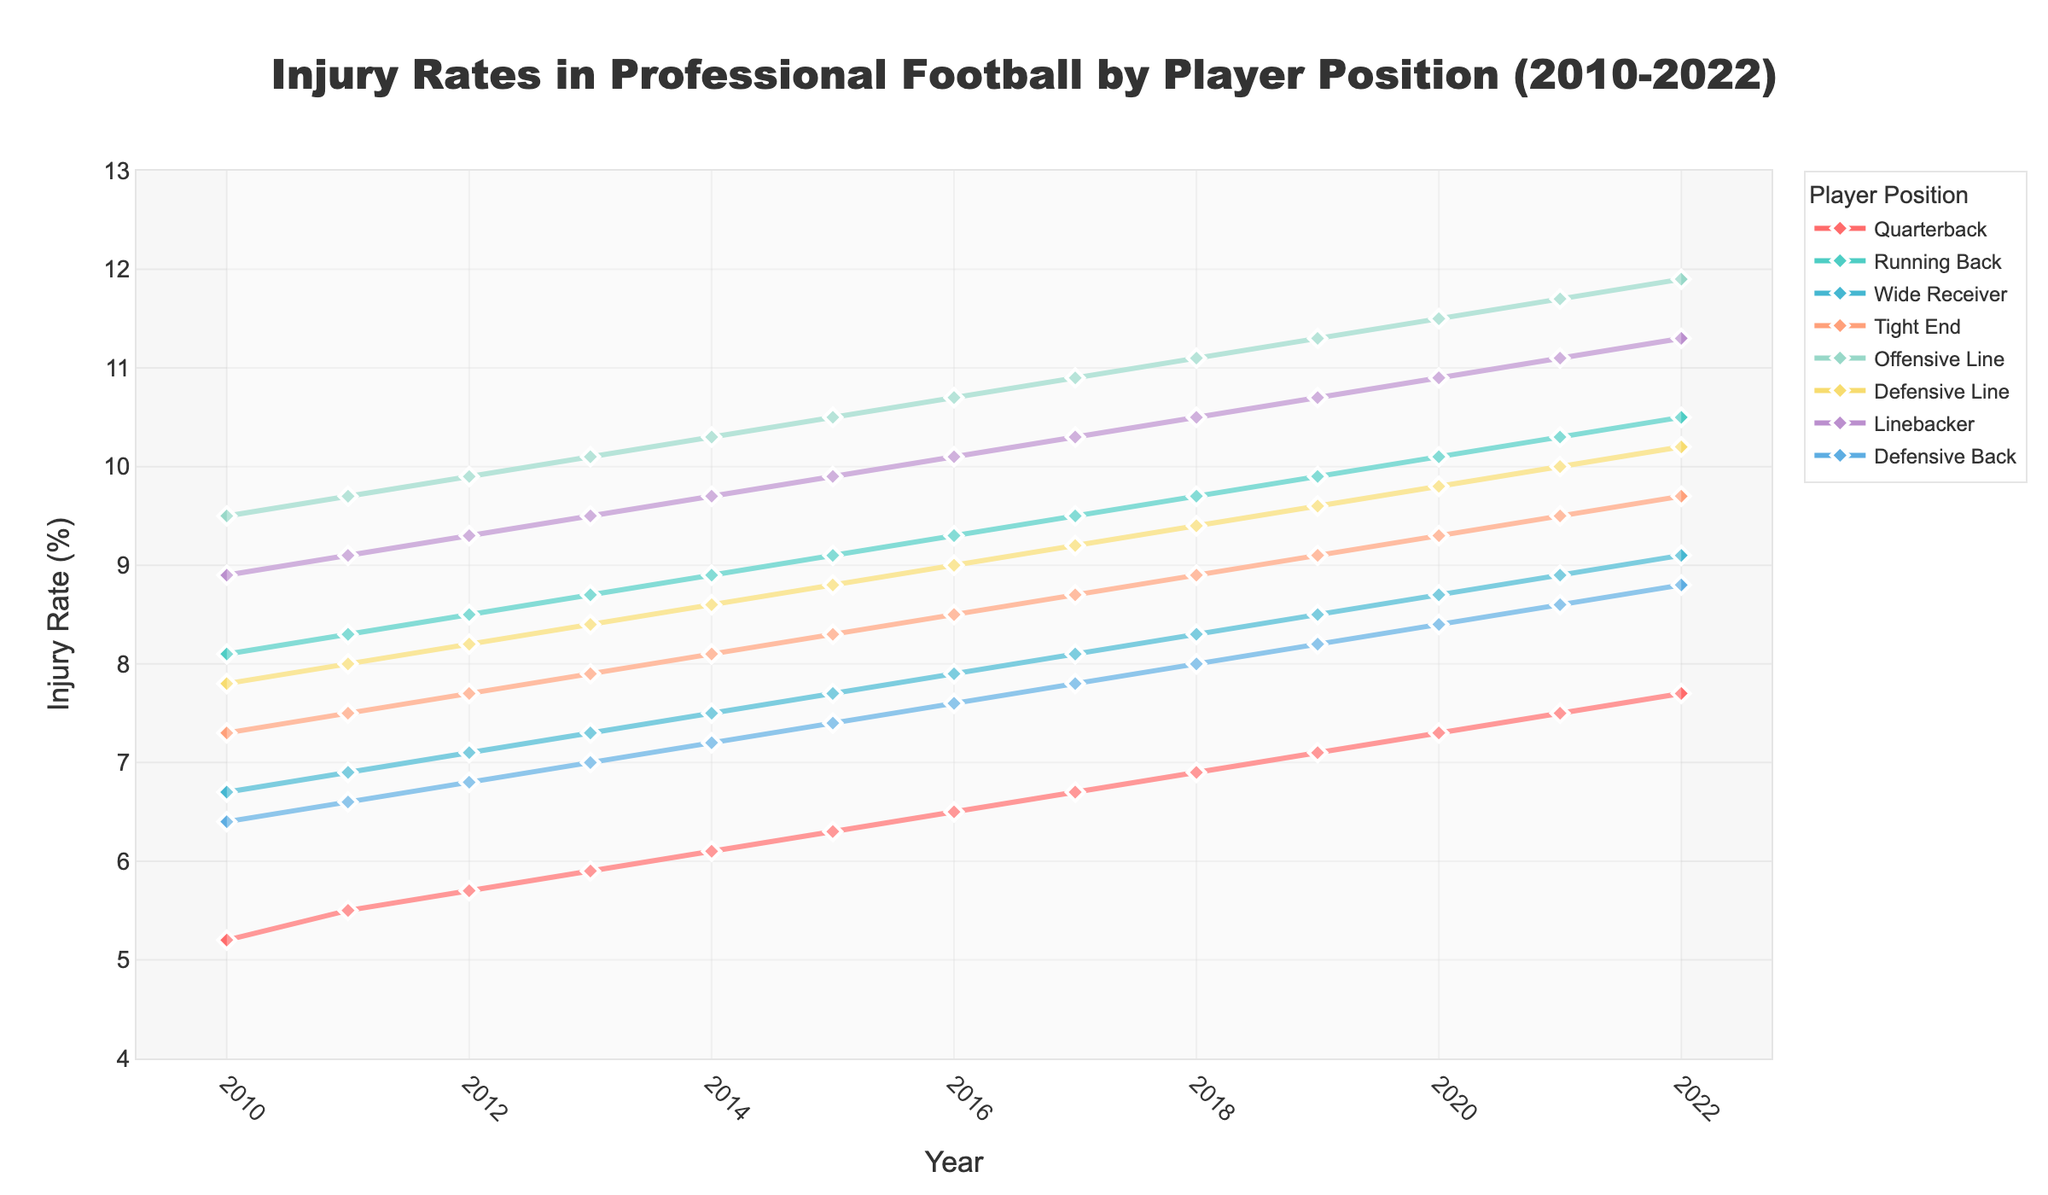Which player position had the highest injury rate in 2022? Look at the injury rates across all player positions for the year 2022. Identify the highest value among them.
Answer: Offensive Line How has the injury rate for Quarterbacks changed from 2010 to 2022? Observe the injury rates for Quarterbacks from 2010 to 2022. Note the initial rate in 2010 and the final rate in 2022 and calculate the difference.
Answer: Increased by 2.5% Which player position shows the most significant increase in injury rates over the years? Compare the starting and ending injury rates for each player position from 2010 to 2022. Determine which position has the largest increase.
Answer: Offensive Line In which year did the Wide Receiver position see the highest injury rate? Review the injury rates for Wide Receivers across all years from 2010 to 2022. Identify the year with the highest rate.
Answer: 2022 What is the average injury rate for Defensive Line players from 2010 to 2022? Calculate the sum of the injury rates for Defensive Line players for each year from 2010 to 2022. Divide the total by the number of years (13).
Answer: 9.2% How do the injury rates for Running Backs and Linebackers compare in 2015? Look at the injury rates for Running Backs and Linebackers in 2015. Compare the values to see which is higher, lower, or if they are equal.
Answer: Linebackers have a higher injury rate Between 2010 and 2022, which position had the least overall variation in injury rates? Determine the range (difference between the highest and lowest values) for each position's injury rate from 2010 to 2022. Find the position with the smallest range.
Answer: Defensive Back What is the overall trend for injury rates in Defensive Backs from 2010 to 2022? Observe the injury rates for Defensive Backs from 2010 to 2022. Identify whether the rates generally increased, decreased, or stayed constant over time.
Answer: Increased How do the injury rates of Wide Receivers in 2010 compare to those in 2022? Look at the specific injury rates for Wide Receivers in the years 2010 and 2022, and compare the two values.
Answer: Increased by 2.4% What is the difference in injury rates between Tight Ends and Offensive Line players in 2022? Identify the injury rates for Tight Ends and Offensive Line players in 2022. Subtract the Tight Ends' rate from the Offensive Line players' rate.
Answer: 2.2% 